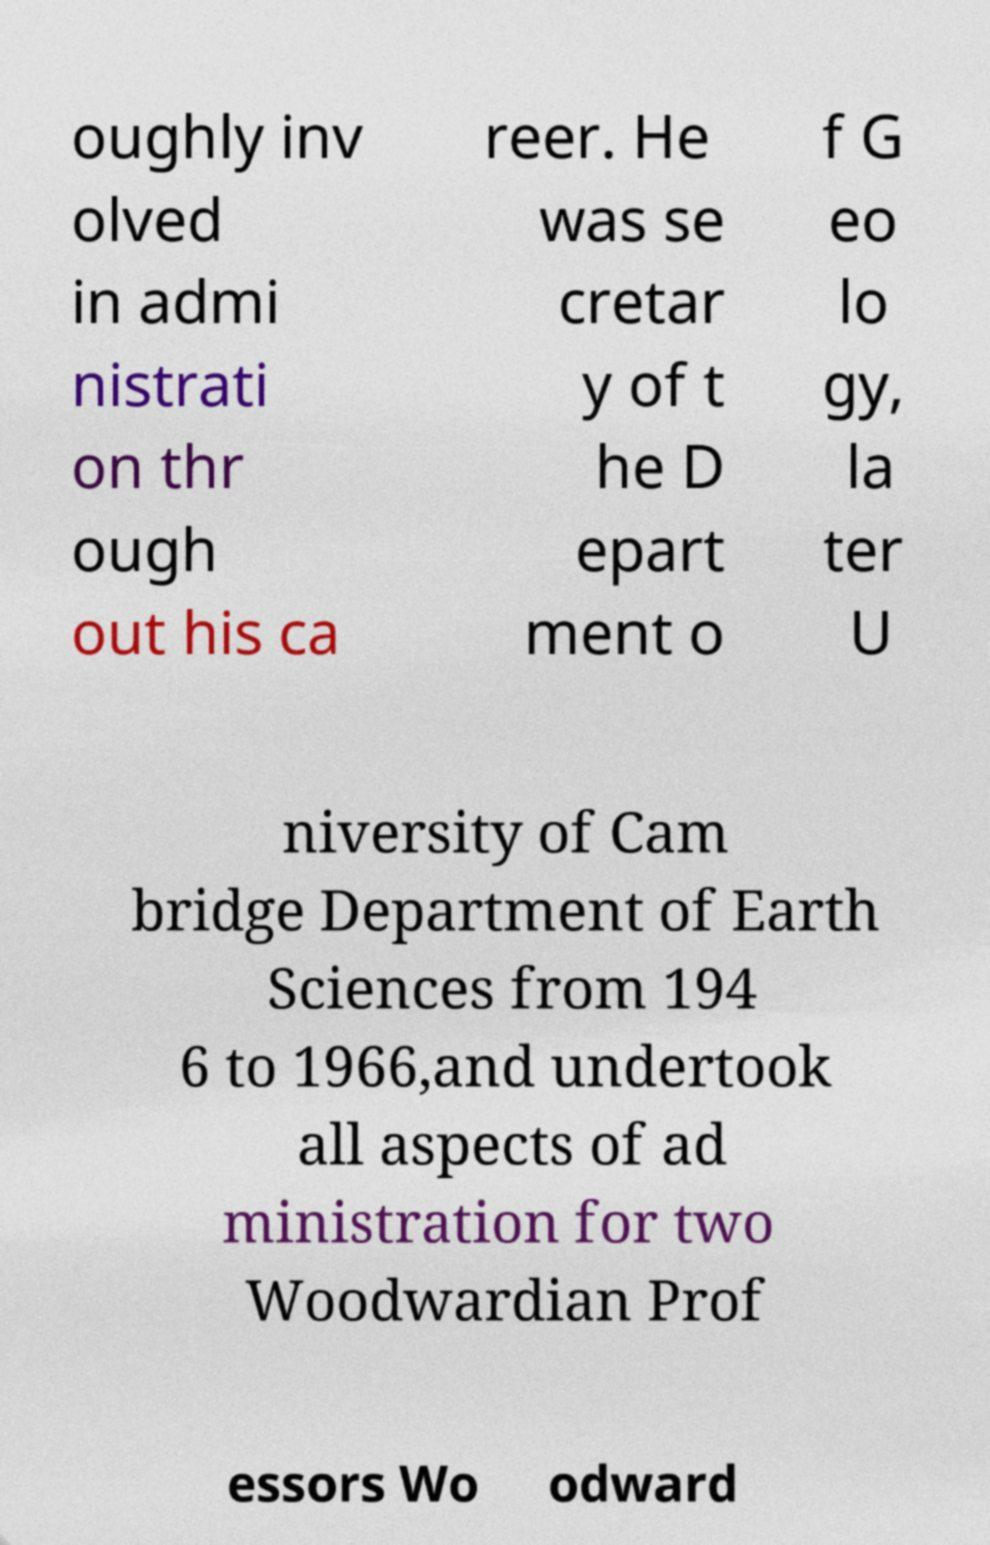For documentation purposes, I need the text within this image transcribed. Could you provide that? oughly inv olved in admi nistrati on thr ough out his ca reer. He was se cretar y of t he D epart ment o f G eo lo gy, la ter U niversity of Cam bridge Department of Earth Sciences from 194 6 to 1966,and undertook all aspects of ad ministration for two Woodwardian Prof essors Wo odward 